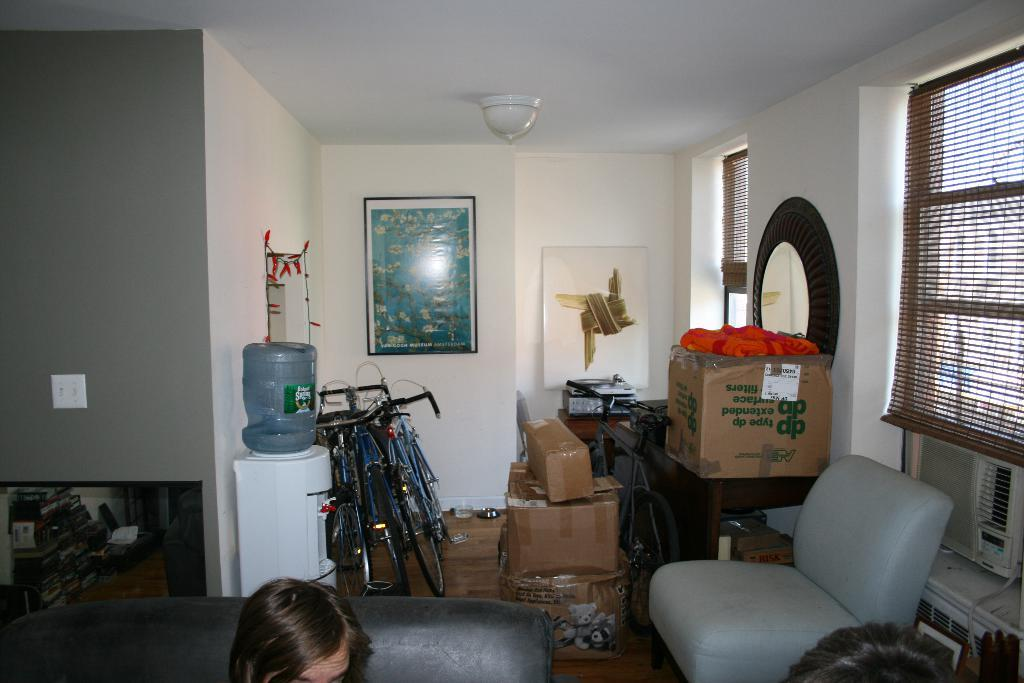What type of vehicles are in the room? There are cycles in the room. What appliance is present in the room for purifying water? There is a water purifier in the room. What type of container is in the room? There is a can in the room. What type of seating is in the room? There is a sofa in the room. What type of storage container is in the room? There is a box in the room. What type of furniture is in the room for placing items? There is a table in the room. What type of lighting is in the room? There is a light in the room. What type of window treatment is in the room? There are curtains in the room. What type of cooling system is in the room? There is an AC in the room. What type of dishware is in the room? There are plates in the room. Can you see any part of a person in the room? A person's head is visible in the room. What type of toothpaste is visible on the table in the room? There is no toothpaste visible on the table in the room. What is the weight of the person whose head is visible in the room? The weight of the person cannot be determined from the image, as only their head is visible. 